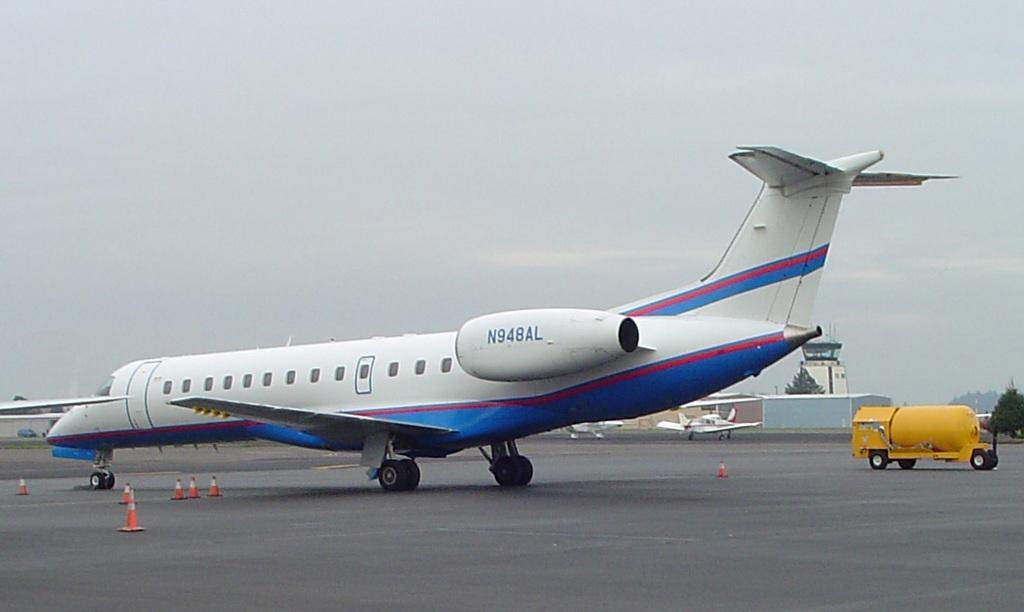Provide a one-sentence caption for the provided image. An airplane with number N948AL sits on a runway. 